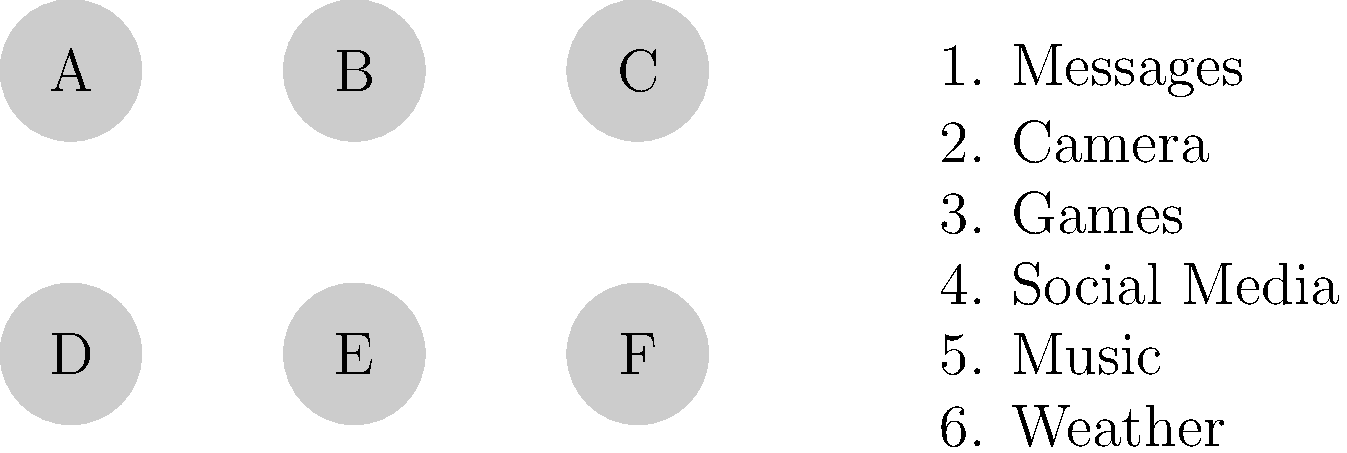Match the app icons (A-F) with their corresponding functions or categories (1-6). Which icon represents the "Camera" function? To answer this question, we need to analyze the icons and their potential representations:

1. Icon A: This could represent a speech bubble, typically associated with messaging apps.
2. Icon B: This appears to be a simple circle, which could represent a camera lens.
3. Icon C: This icon doesn't have a clear association with any of the listed functions.
4. Icon D: This icon also lacks a clear association with the given functions.
5. Icon E: This icon doesn't have a distinct representation for any of the listed functions.
6. Icon F: This icon also doesn't clearly represent any of the given functions.

Among these options, Icon B most closely resembles a camera lens, which is commonly used to represent camera apps or functions on mobile devices. Therefore, the icon that best represents the "Camera" function is B.
Answer: B 